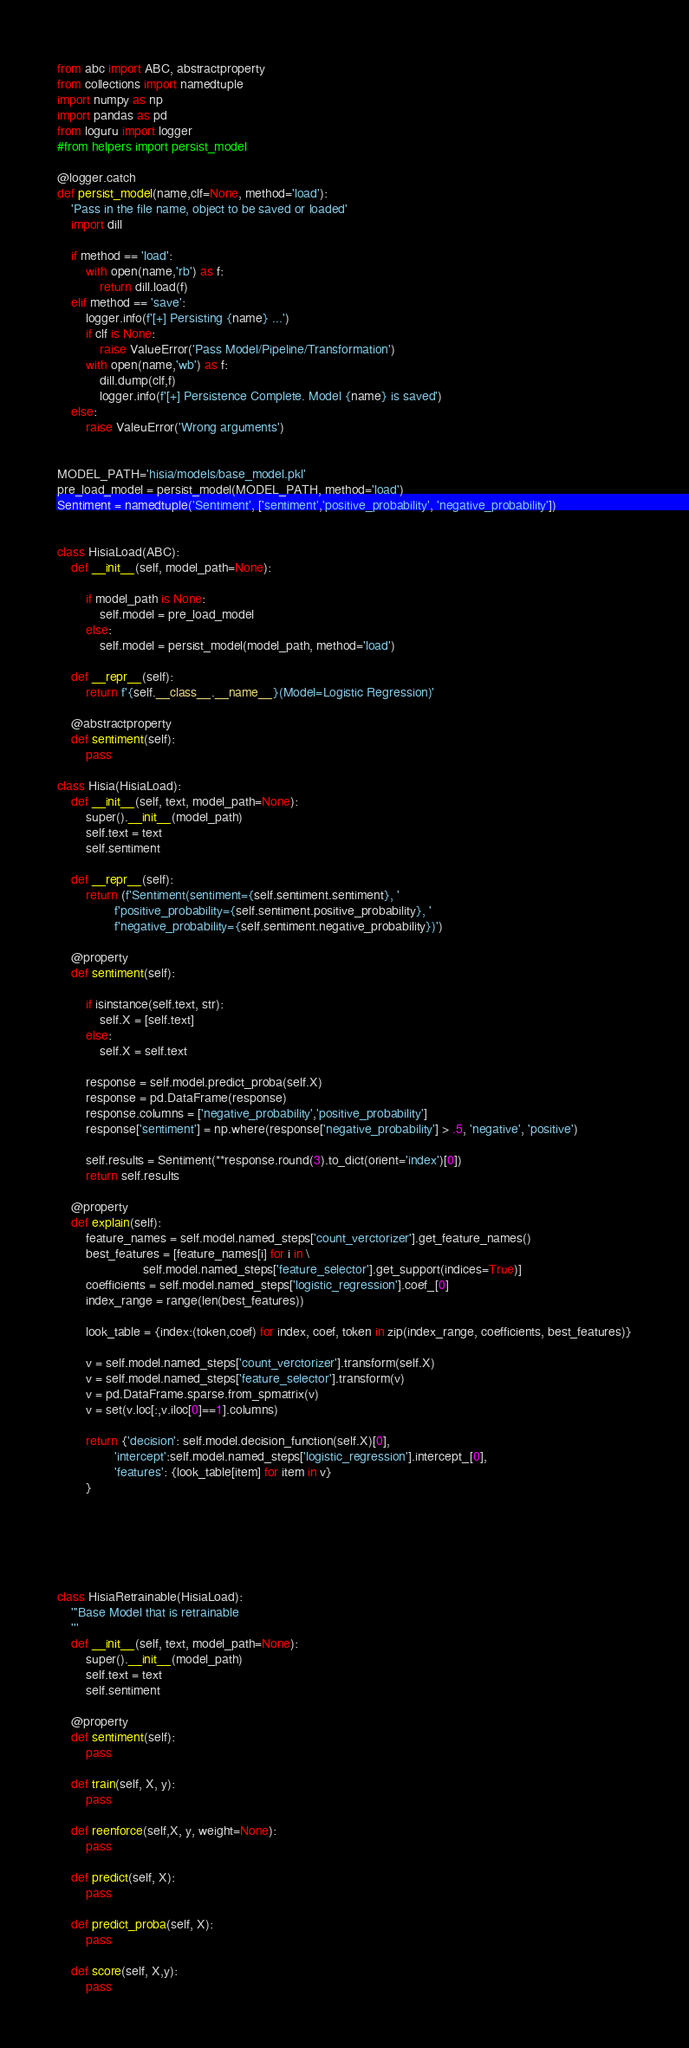<code> <loc_0><loc_0><loc_500><loc_500><_Python_>from abc import ABC, abstractproperty
from collections import namedtuple
import numpy as np
import pandas as pd
from loguru import logger
#from helpers import persist_model

@logger.catch
def persist_model(name,clf=None, method='load'):
    'Pass in the file name, object to be saved or loaded'
    import dill
    
    if method == 'load':
        with open(name,'rb') as f:
            return dill.load(f)
    elif method == 'save':
        logger.info(f'[+] Persisting {name} ...')
        if clf is None:
            raise ValueError('Pass Model/Pipeline/Transformation')
        with open(name,'wb') as f:
            dill.dump(clf,f)
            logger.info(f'[+] Persistence Complete. Model {name} is saved')
    else:
        raise ValeuError('Wrong arguments')


MODEL_PATH='hisia/models/base_model.pkl'
pre_load_model = persist_model(MODEL_PATH, method='load')
Sentiment = namedtuple('Sentiment', ['sentiment','positive_probability', 'negative_probability'])


class HisiaLoad(ABC):
    def __init__(self, model_path=None):
    
        if model_path is None:
            self.model = pre_load_model
        else:
            self.model = persist_model(model_path, method='load') 

    def __repr__(self):
        return f'{self.__class__.__name__}(Model=Logistic Regression)'

    @abstractproperty
    def sentiment(self):
        pass

class Hisia(HisiaLoad):
    def __init__(self, text, model_path=None):
        super().__init__(model_path)
        self.text = text
        self.sentiment

    def __repr__(self):
        return (f'Sentiment(sentiment={self.sentiment.sentiment}, '
                f'positive_probability={self.sentiment.positive_probability}, '
                f'negative_probability={self.sentiment.negative_probability})')

    @property
    def sentiment(self):
        
        if isinstance(self.text, str):
            self.X = [self.text]
        else:
            self.X = self.text

        response = self.model.predict_proba(self.X)
        response = pd.DataFrame(response)
        response.columns = ['negative_probability','positive_probability']
        response['sentiment'] = np.where(response['negative_probability'] > .5, 'negative', 'positive')

        self.results = Sentiment(**response.round(3).to_dict(orient='index')[0])
        return self.results

    @property
    def explain(self):
        feature_names = self.model.named_steps['count_verctorizer'].get_feature_names()
        best_features = [feature_names[i] for i in \
                        self.model.named_steps['feature_selector'].get_support(indices=True)]
        coefficients = self.model.named_steps['logistic_regression'].coef_[0]
        index_range = range(len(best_features))

        look_table = {index:(token,coef) for index, coef, token in zip(index_range, coefficients, best_features)}

        v = self.model.named_steps['count_verctorizer'].transform(self.X)
        v = self.model.named_steps['feature_selector'].transform(v)
        v = pd.DataFrame.sparse.from_spmatrix(v)
        v = set(v.loc[:,v.iloc[0]==1].columns)

        return {'decision': self.model.decision_function(self.X)[0],
                'intercept':self.model.named_steps['logistic_regression'].intercept_[0],
                'features': {look_table[item] for item in v}
        }
        





class HisiaRetrainable(HisiaLoad):
    '''Base Model that is retrainable
    '''
    def __init__(self, text, model_path=None):
        super().__init__(model_path)
        self.text = text
        self.sentiment

    @property
    def sentiment(self):
        pass

    def train(self, X, y):
        pass

    def reenforce(self,X, y, weight=None):
        pass

    def predict(self, X):
        pass

    def predict_proba(self, X):
        pass

    def score(self, X,y):
        pass</code> 